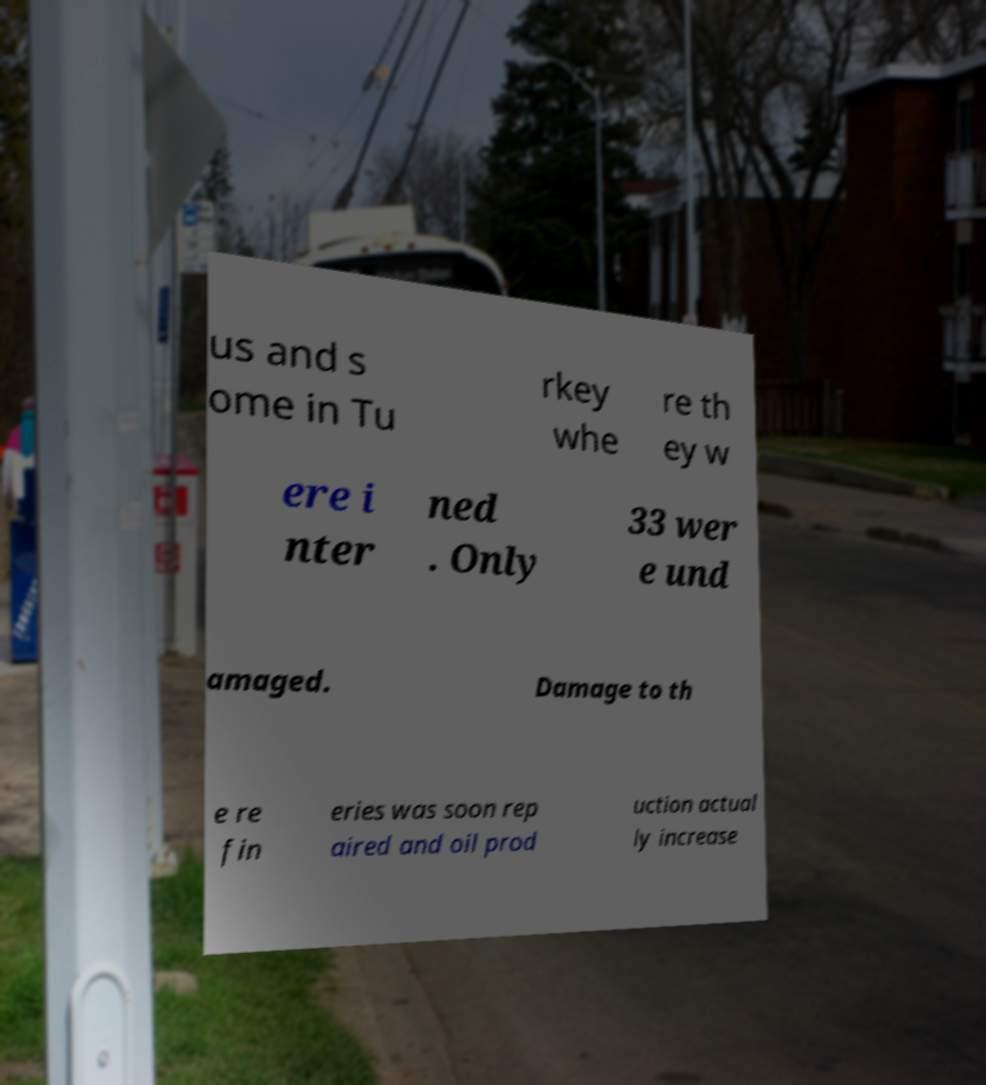What messages or text are displayed in this image? I need them in a readable, typed format. us and s ome in Tu rkey whe re th ey w ere i nter ned . Only 33 wer e und amaged. Damage to th e re fin eries was soon rep aired and oil prod uction actual ly increase 